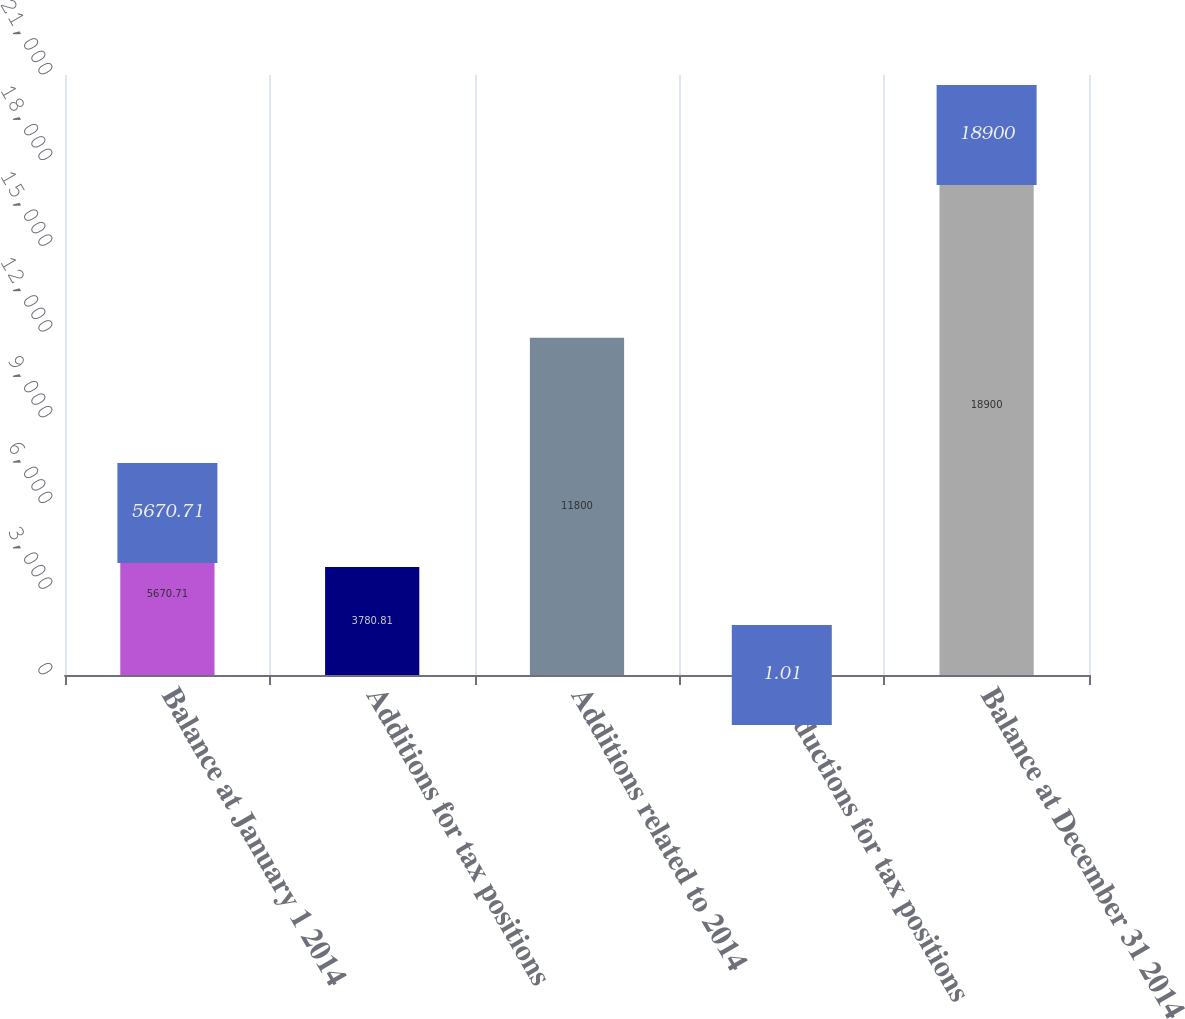Convert chart. <chart><loc_0><loc_0><loc_500><loc_500><bar_chart><fcel>Balance at January 1 2014<fcel>Additions for tax positions<fcel>Additions related to 2014<fcel>Reductions for tax positions<fcel>Balance at December 31 2014<nl><fcel>5670.71<fcel>3780.81<fcel>11800<fcel>1.01<fcel>18900<nl></chart> 